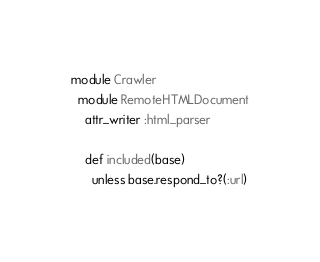Convert code to text. <code><loc_0><loc_0><loc_500><loc_500><_Ruby_>module Crawler
  module RemoteHTMLDocument
    attr_writer :html_parser

    def included(base)
      unless base.respond_to?(:url)</code> 